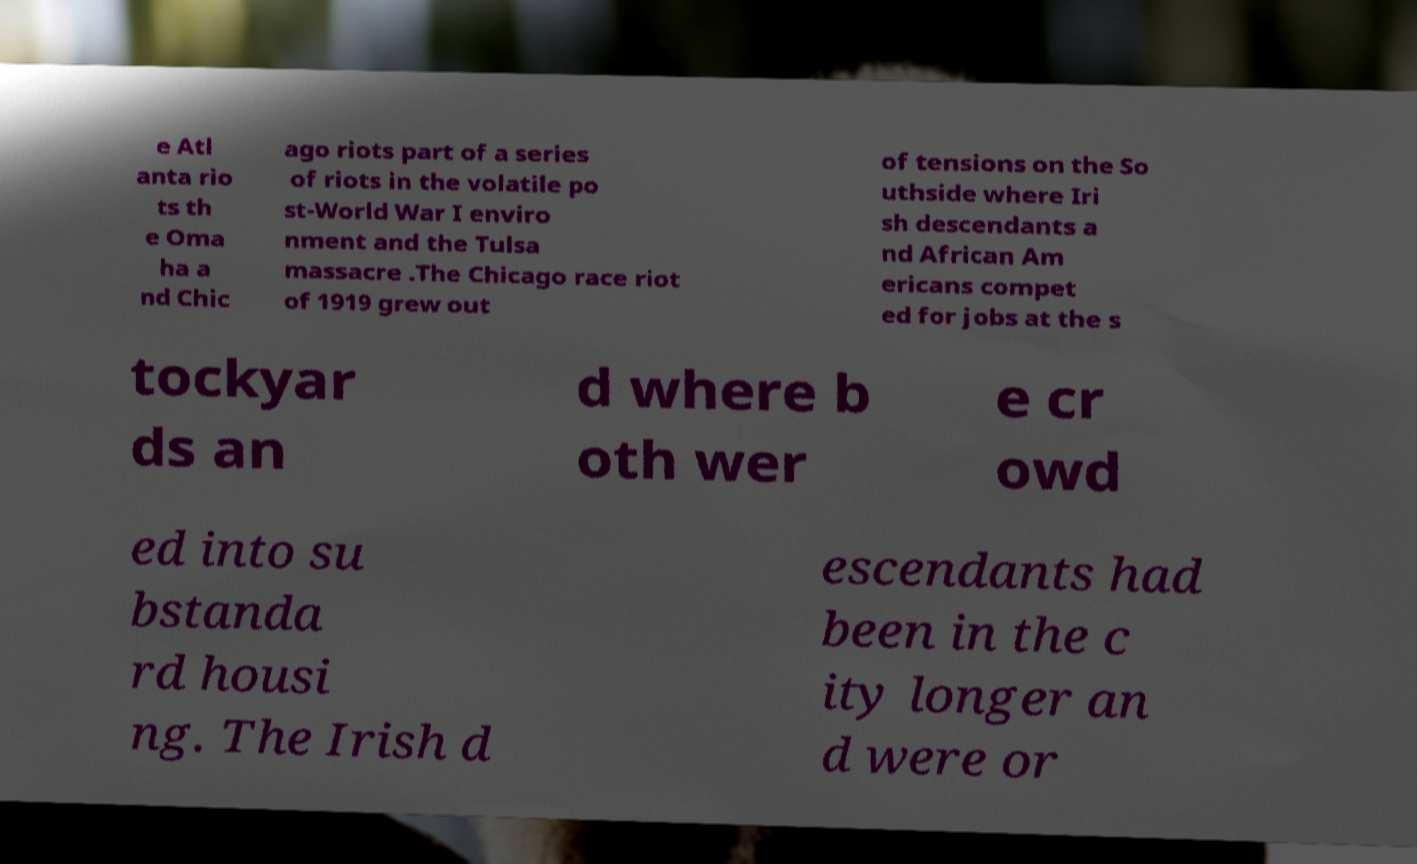Can you read and provide the text displayed in the image?This photo seems to have some interesting text. Can you extract and type it out for me? e Atl anta rio ts th e Oma ha a nd Chic ago riots part of a series of riots in the volatile po st-World War I enviro nment and the Tulsa massacre .The Chicago race riot of 1919 grew out of tensions on the So uthside where Iri sh descendants a nd African Am ericans compet ed for jobs at the s tockyar ds an d where b oth wer e cr owd ed into su bstanda rd housi ng. The Irish d escendants had been in the c ity longer an d were or 